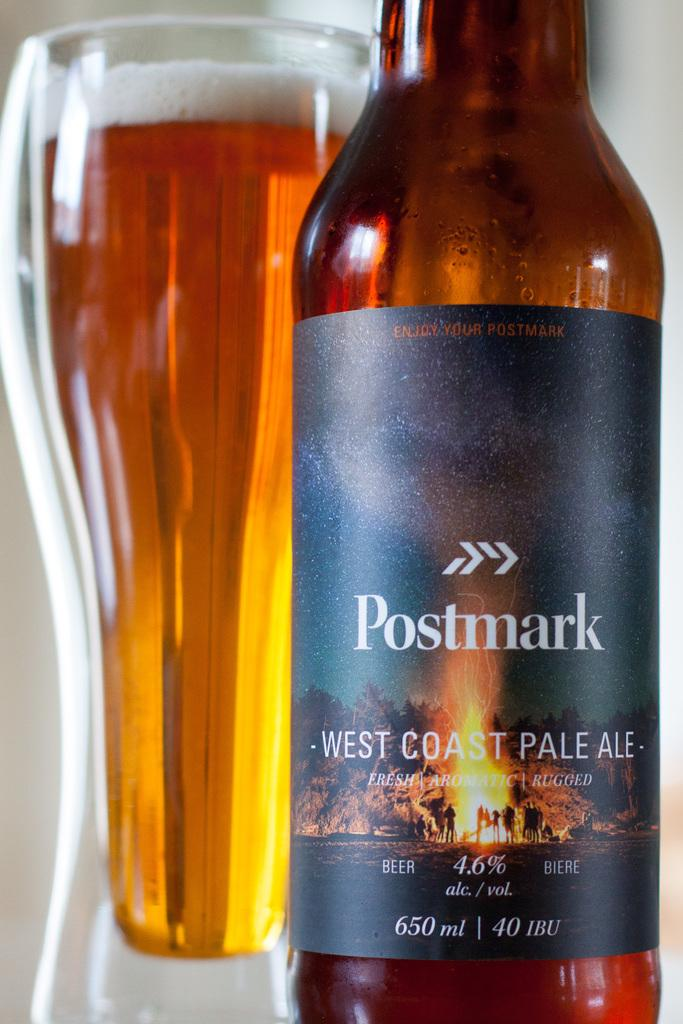Provide a one-sentence caption for the provided image. A Postmark brand bottle of pale ale sits next to a full glass. 